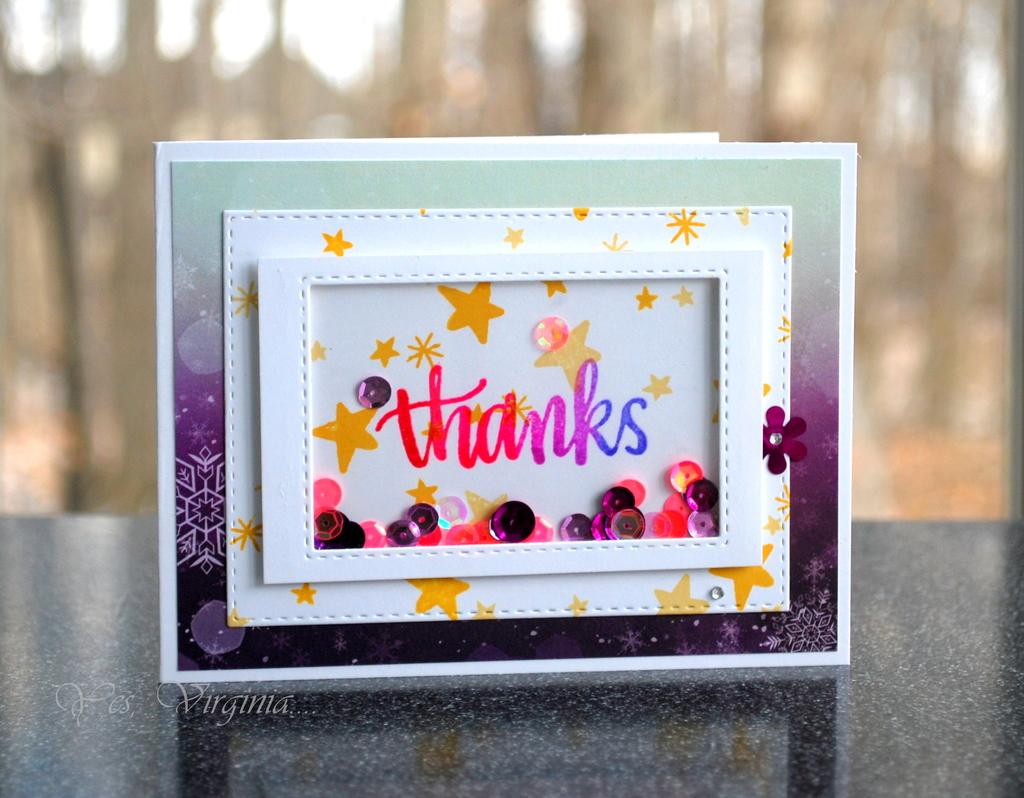<image>
Share a concise interpretation of the image provided. A colorful framed thanks poster standing on a black marble surface. 